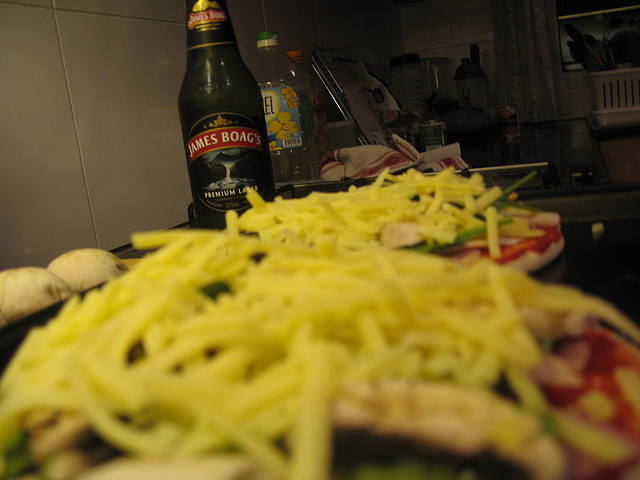Identify the text displayed in this image. JAMES BOAG'S IUMIUM EL 